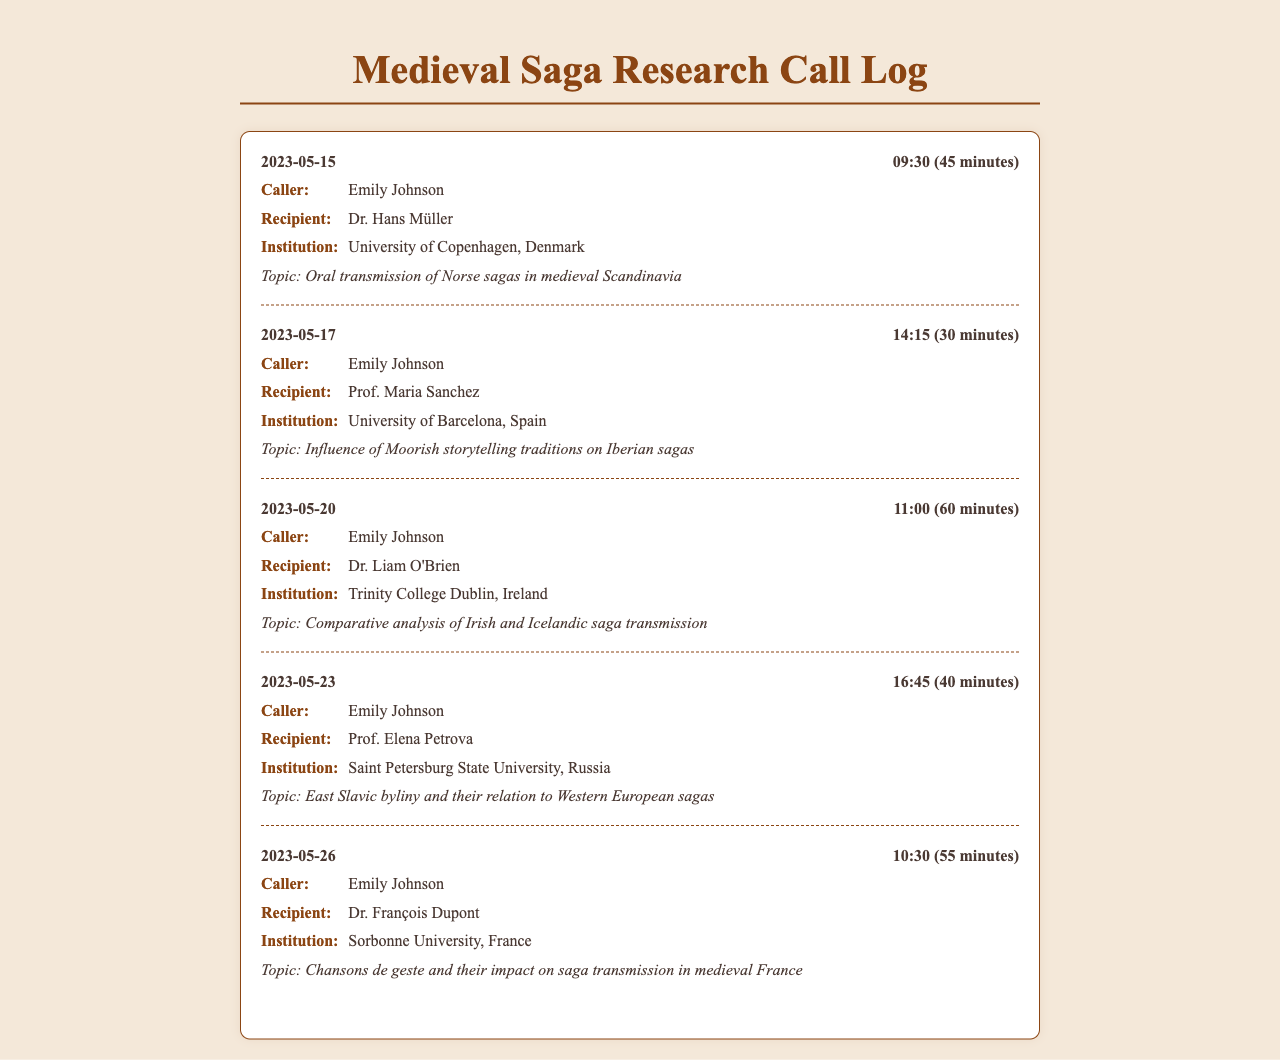What is the date of the first call? The first call entry is dated 2023-05-15.
Answer: 2023-05-15 Who is the recipient of the call on May 20th? The call on May 20th was to Dr. Liam O'Brien.
Answer: Dr. Liam O'Brien What was the duration of the call with Prof. Maria Sanchez? The duration of the call is noted as 30 minutes.
Answer: 30 minutes Which topic was discussed during the call with Dr. François Dupont? The topic of discussion with Dr. François Dupont was "Chansons de geste and their impact on saga transmission in medieval France".
Answer: Chansons de geste and their impact on saga transmission in medieval France How many calls were made to institutions outside of Scandinavia? There were three calls made to institutions outside of Scandinavia (Spain, Ireland, and Russia).
Answer: three Which institution does Prof. Elena Petrova belong to? Prof. Elena Petrova is associated with Saint Petersburg State University.
Answer: Saint Petersburg State University What is the main focus of the call with Dr. Hans Müller? The main focus is on the "Oral transmission of Norse sagas in medieval Scandinavia".
Answer: Oral transmission of Norse sagas in medieval Scandinavia What was the time of the call on May 26th? The call on May 26th was made at 10:30.
Answer: 10:30 Which country is the University of Barcelona located in? The University of Barcelona is located in Spain.
Answer: Spain 